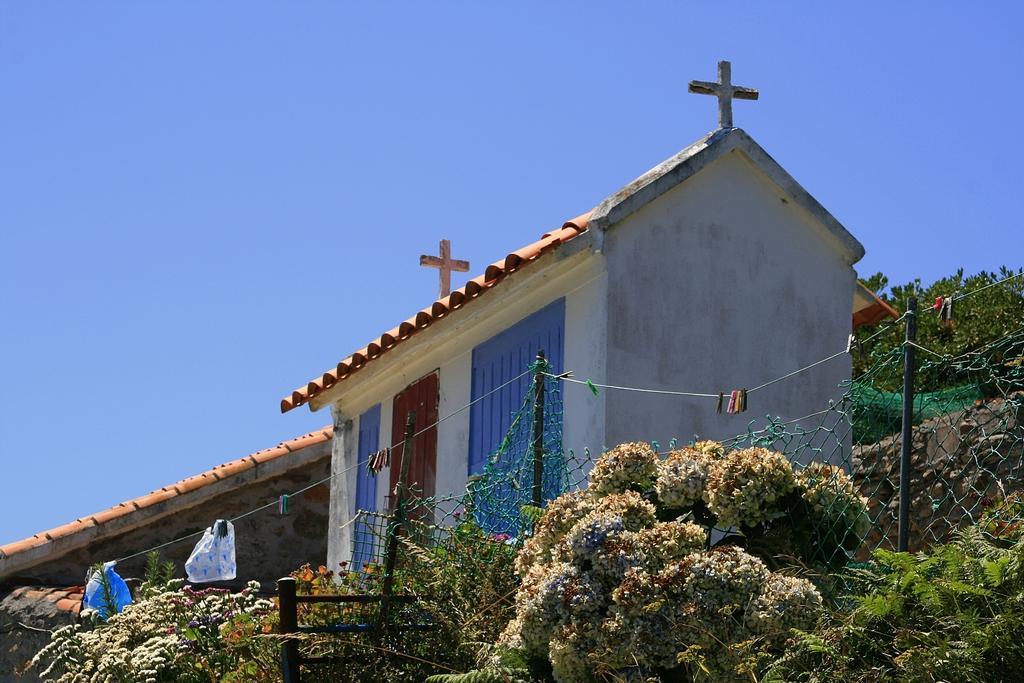Describe this image in one or two sentences. In this image there are plants, grass, iron fence, poles, clothes on the ropes, house, sky. 